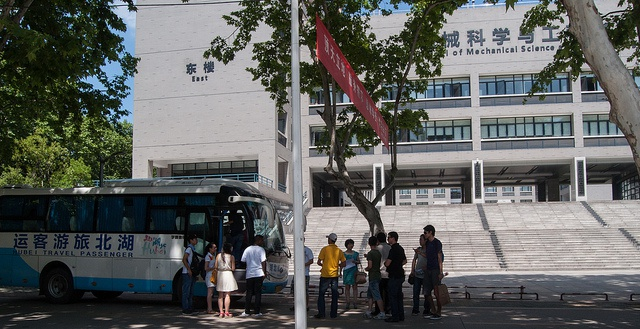Describe the objects in this image and their specific colors. I can see bus in black, gray, darkblue, and purple tones, people in black, gray, maroon, and darkgray tones, people in black, gray, and darkgray tones, people in black, maroon, and gray tones, and people in black, maroon, and olive tones in this image. 